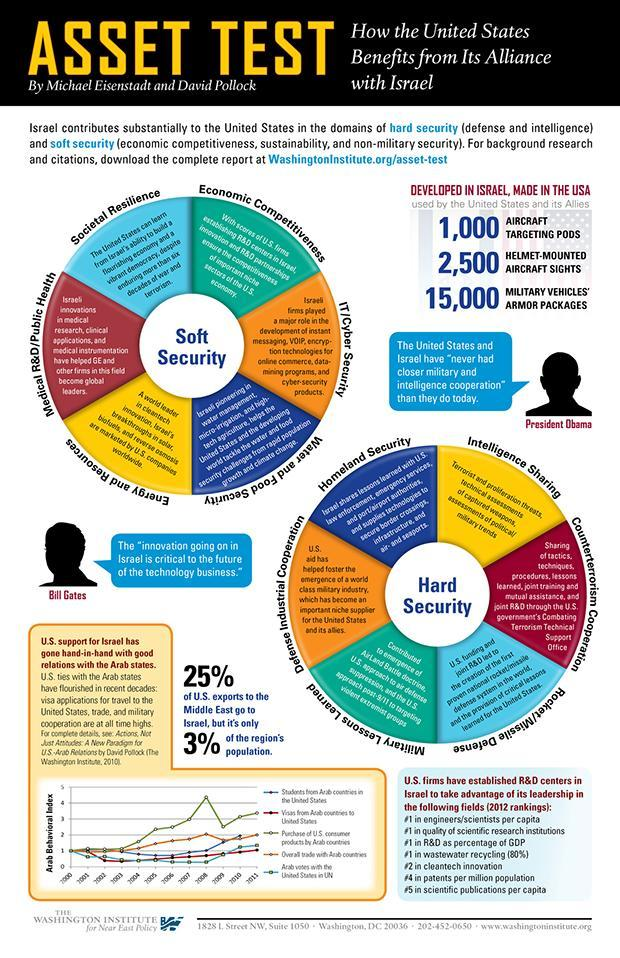In how many different fields U.S. take advantage of Israel?
Answer the question with a short phrase. 7 What percentage of U. S. exports to the middle east does not go to Israel? 75 In which year Overall trade with Arab countries is the highest? 2008 In which year highest number Arab students reached America? 2010 Into how many parts Hard Security is divided? 6 Into how many parts Soft Security is divided? 6 In which year Purchase of consumer products from America by Arab countries is the highest? 2008 